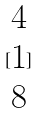Convert formula to latex. <formula><loc_0><loc_0><loc_500><loc_500>[ \begin{matrix} 4 \\ 1 \\ 8 \end{matrix} ]</formula> 